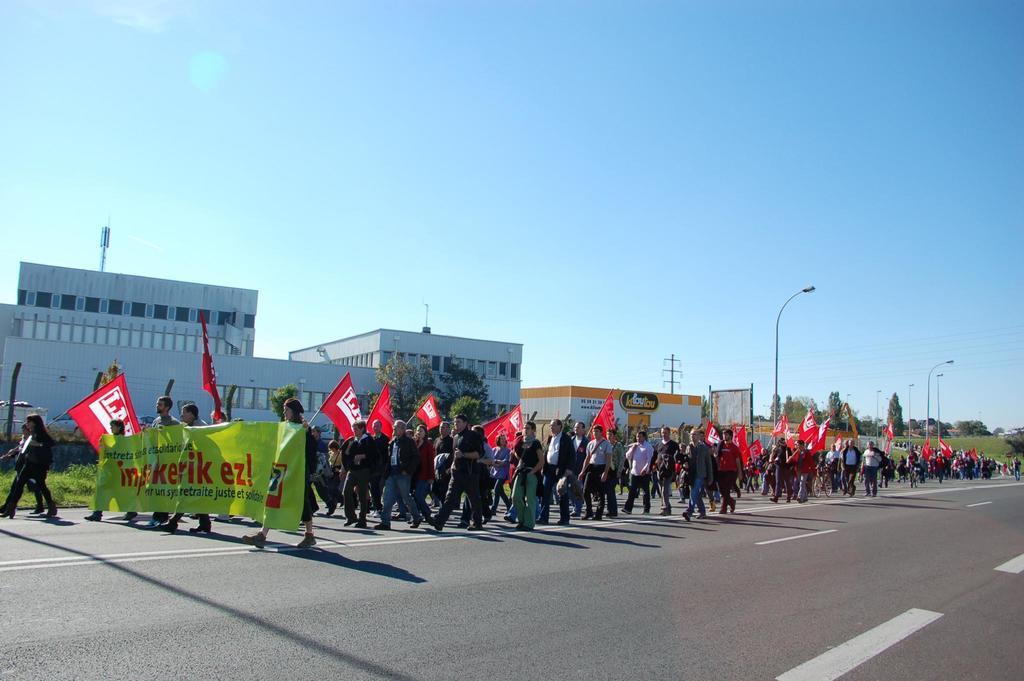Please provide a concise description of this image. This image is clicked outside. There are so many people in the middle, who are holding flags. And some people are holding banners on the left side. There is building in the middle. There are trees on the right side. There are lights in the middle. There is sky at the top. 